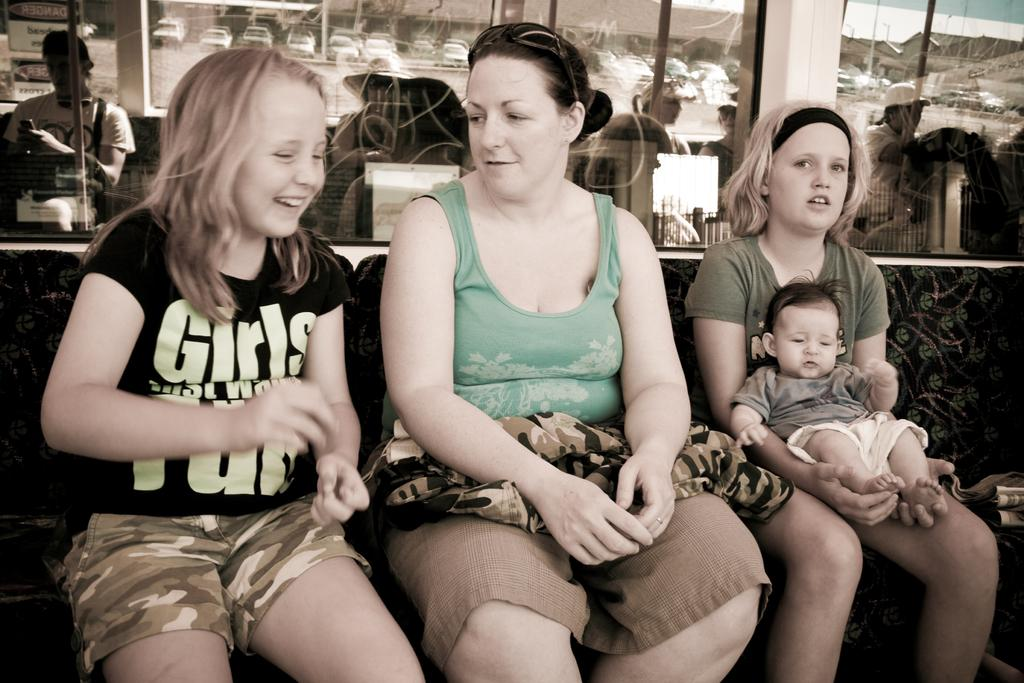How many people are sitting on the chair in the image? There are three persons sitting on a chair in the image. What can be seen in the background of the image? There is a glass, a wall, and cars present in the background of the image. What type of caption is written on the wall in the image? There is no caption written on the wall in the image. Can you describe the wave pattern on the glass in the image? There is no wave pattern on the glass in the image; it is a simple glass. 